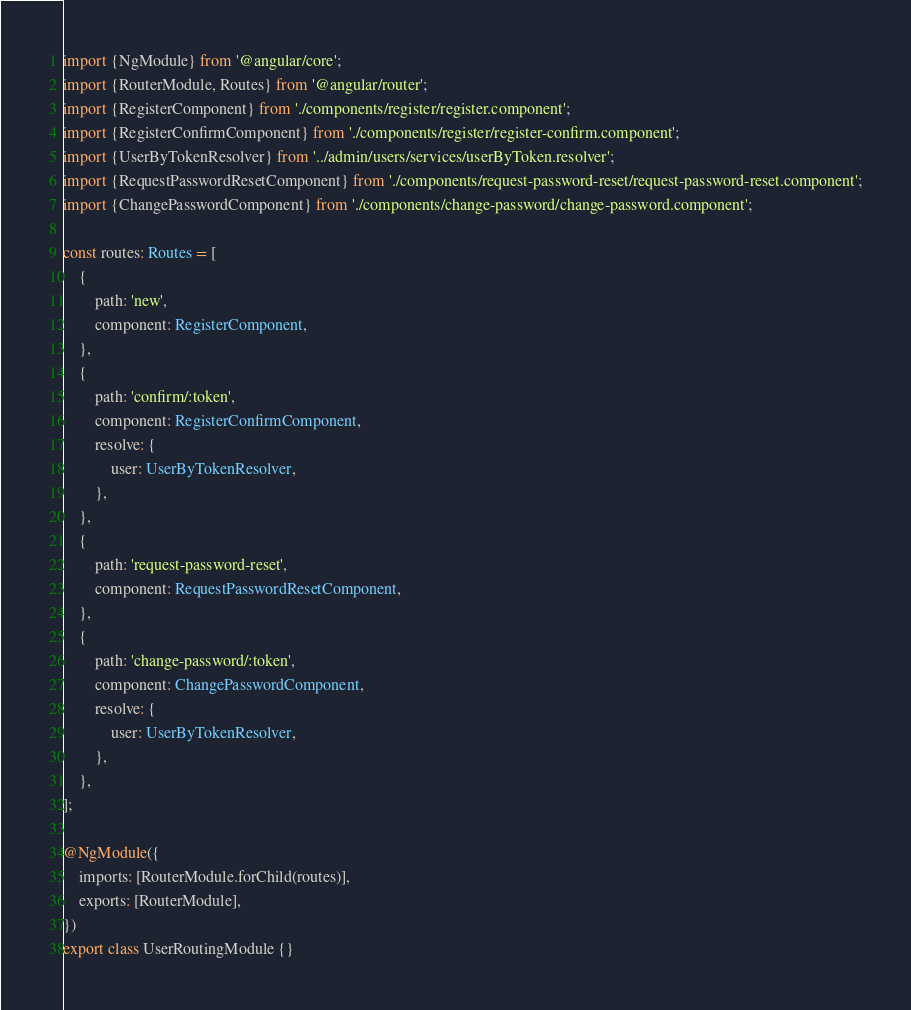Convert code to text. <code><loc_0><loc_0><loc_500><loc_500><_TypeScript_>import {NgModule} from '@angular/core';
import {RouterModule, Routes} from '@angular/router';
import {RegisterComponent} from './components/register/register.component';
import {RegisterConfirmComponent} from './components/register/register-confirm.component';
import {UserByTokenResolver} from '../admin/users/services/userByToken.resolver';
import {RequestPasswordResetComponent} from './components/request-password-reset/request-password-reset.component';
import {ChangePasswordComponent} from './components/change-password/change-password.component';

const routes: Routes = [
    {
        path: 'new',
        component: RegisterComponent,
    },
    {
        path: 'confirm/:token',
        component: RegisterConfirmComponent,
        resolve: {
            user: UserByTokenResolver,
        },
    },
    {
        path: 'request-password-reset',
        component: RequestPasswordResetComponent,
    },
    {
        path: 'change-password/:token',
        component: ChangePasswordComponent,
        resolve: {
            user: UserByTokenResolver,
        },
    },
];

@NgModule({
    imports: [RouterModule.forChild(routes)],
    exports: [RouterModule],
})
export class UserRoutingModule {}
</code> 